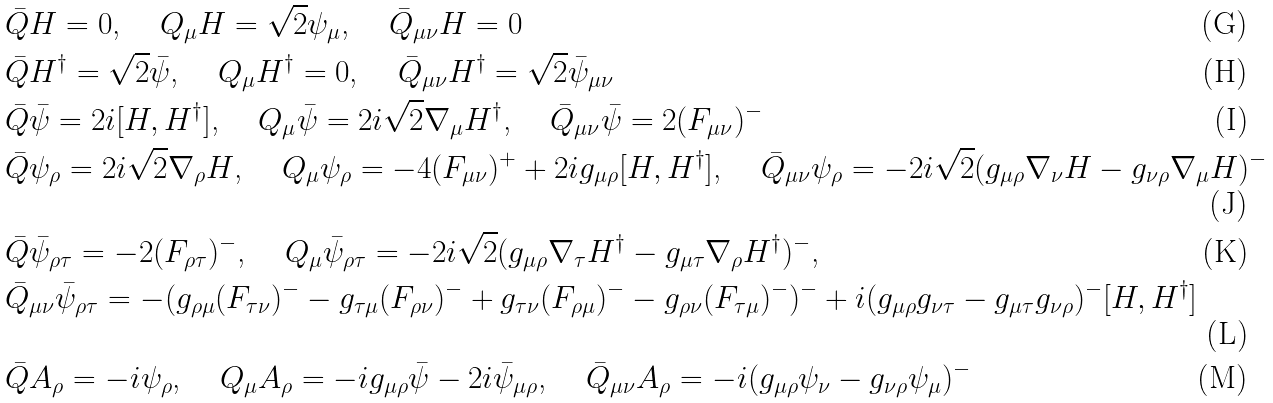Convert formula to latex. <formula><loc_0><loc_0><loc_500><loc_500>& \bar { Q } H = 0 \text {, } \quad Q _ { \mu } H = \sqrt { 2 } \psi _ { \mu } \text {, } \quad \bar { Q } _ { \mu \nu } H = 0 \\ & \bar { Q } H ^ { \dagger } = \sqrt { 2 } \bar { \psi } \text {, } \quad Q _ { \mu } H ^ { \dagger } = 0 \text {, } \quad \bar { Q } _ { \mu \nu } H ^ { \dagger } = \sqrt { 2 } \bar { \psi } _ { \mu \nu } \\ & \bar { Q } \bar { \psi } = 2 i [ H , H ^ { \dagger } ] \text {, } \quad Q _ { \mu } \bar { \psi } = 2 i \sqrt { 2 } \nabla _ { \mu } H ^ { \dagger } \text {, } \quad \bar { Q } _ { \mu \nu } \bar { \psi } = 2 ( F _ { \mu \nu } ) ^ { - } \\ & \bar { Q } \psi _ { \rho } = 2 i \sqrt { 2 } \nabla _ { \rho } H \text {, } \quad Q _ { \mu } \psi _ { \rho } = - 4 ( F _ { \mu \nu } ) ^ { + } + 2 i g _ { \mu \rho } [ H , H ^ { \dagger } ] \text {, } \quad \bar { Q } _ { \mu \nu } \psi _ { \rho } = - 2 i \sqrt { 2 } ( g _ { \mu \rho } \nabla _ { \nu } H - g _ { \nu \rho } \nabla _ { \mu } H ) ^ { - } \\ & \bar { Q } \bar { \psi } _ { \rho \tau } = - 2 ( F _ { \rho \tau } ) ^ { - } \text {, } \quad Q _ { \mu } \bar { \psi } _ { \rho \tau } = - 2 i \sqrt { 2 } ( g _ { \mu \rho } \nabla _ { \tau } H ^ { \dagger } - g _ { \mu \tau } \nabla _ { \rho } H ^ { \dagger } ) ^ { - } \text {, } \quad \\ & \bar { Q } _ { \mu \nu } \bar { \psi } _ { \rho \tau } = - ( g _ { \rho \mu } ( F _ { \tau \nu } ) ^ { - } - g _ { \tau \mu } ( F _ { \rho \nu } ) ^ { - } + g _ { \tau \nu } ( F _ { \rho \mu } ) ^ { - } - g _ { \rho \nu } ( F _ { \tau \mu } ) ^ { - } ) ^ { - } + i ( g _ { \mu \rho } g _ { \nu \tau } - g _ { \mu \tau } g _ { \nu \rho } ) ^ { - } [ H , H ^ { \dagger } ] \\ & \bar { Q } A _ { \rho } = - i \psi _ { \rho } \text {, } \quad Q _ { \mu } A _ { \rho } = - i g _ { \mu \rho } \bar { \psi } - 2 i \bar { \psi } _ { \mu \rho } \text {, } \quad \bar { Q } _ { \mu \nu } A _ { \rho } = - i ( g _ { \mu \rho } \psi _ { \nu } - g _ { \nu \rho } \psi _ { \mu } ) ^ { - }</formula> 